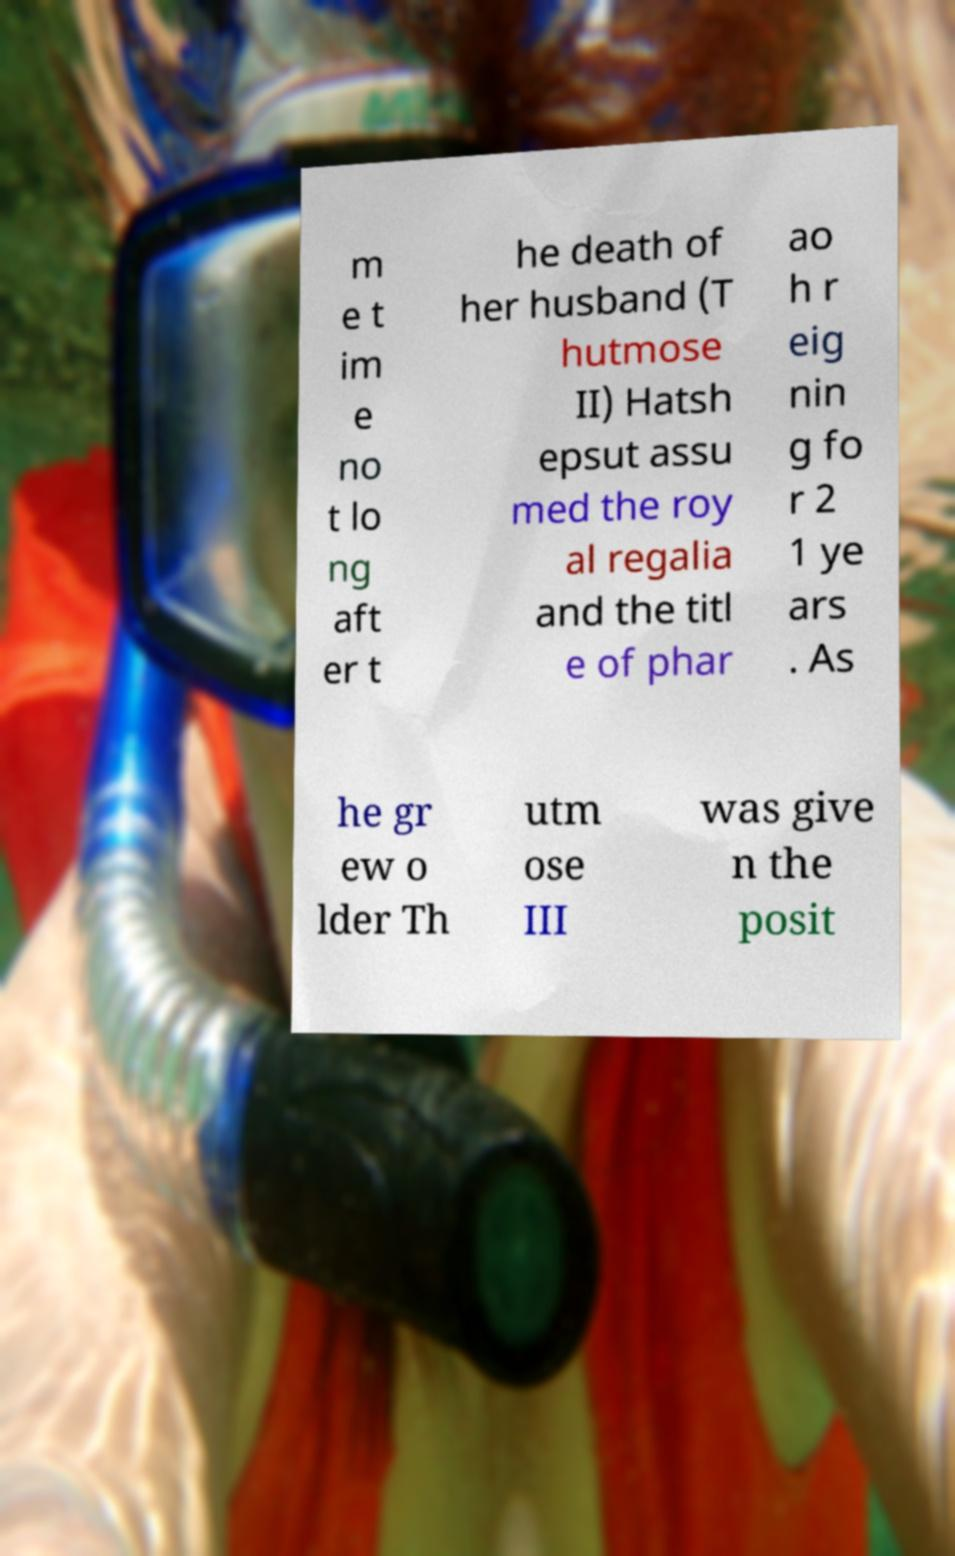I need the written content from this picture converted into text. Can you do that? m e t im e no t lo ng aft er t he death of her husband (T hutmose II) Hatsh epsut assu med the roy al regalia and the titl e of phar ao h r eig nin g fo r 2 1 ye ars . As he gr ew o lder Th utm ose III was give n the posit 